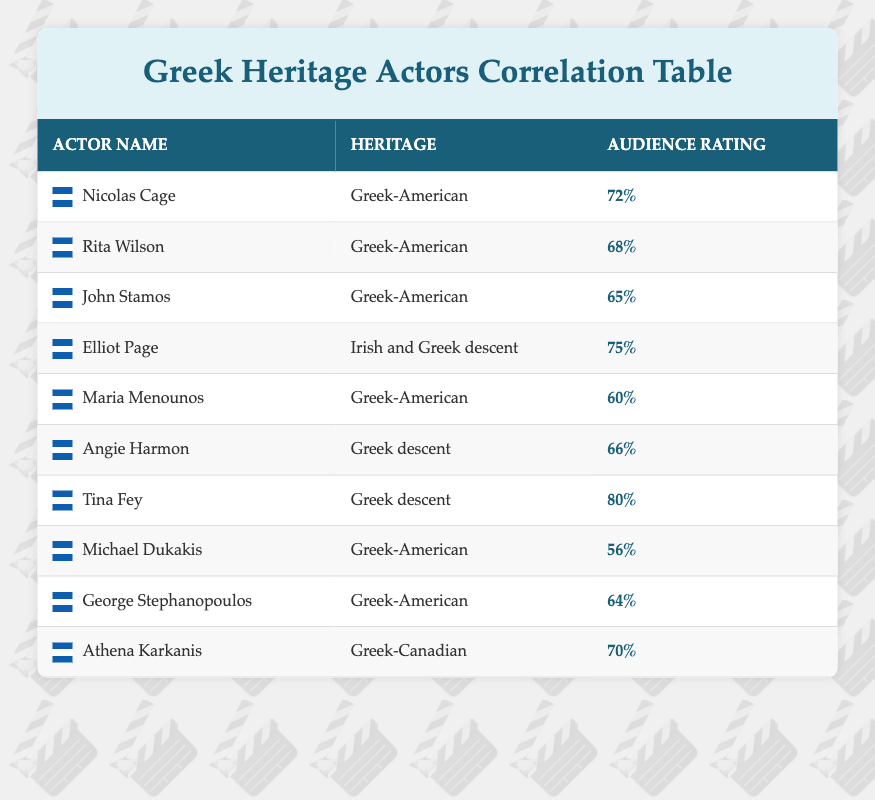What is the highest audience rating among the actors listed? To find the highest audience rating, we need to compare the numbers in the "Audience Rating" column. The highest rating is observed for Tina Fey, who has a rating of 80%.
Answer: 80% Which actor has the lowest audience rating? By examining the "Audience Rating" values, we find that Michael Dukakis has the lowest rating at 56%.
Answer: 56% How many actors have Greek-American heritage? We need to count the entries in the "Heritage" column that specifically list "Greek-American." There are 5 actors: Nicolas Cage, Rita Wilson, John Stamos, Maria Menounos, and Michael Dukakis.
Answer: 5 What is the average audience rating of actors with solely "Greek descent"? The actors with solely "Greek descent" are Elliot Page, Tina Fey, and Angie Harmon, with ratings of 75%, 80%, and 66% respectively. To find the average, we add these ratings: 75 + 80 + 66 = 221, and then divide by 3 (the number of actors): 221 / 3 = 73.67. The average is approximately 73.67%.
Answer: 73.67% Is there an actor with both Greek and Irish heritage in the list? We can scan the "Heritage" column to check for any actors listed with "Irish" heritage combined with Greek. Elliot Page is the only actor with this combined heritage.
Answer: Yes What is the total audience rating for all the Greek-American actors? The following actors are Greek-American: Nicolas Cage (72%), Rita Wilson (68%), John Stamos (65%), Maria Menounos (60%), and Michael Dukakis (56%). Adding these together gives us: 72 + 68 + 65 + 60 + 56 = 321.
Answer: 321 Are there more actors with Greek-American heritage or those with Greek descent? The count of Greek-American actors is 5 (Nicolas Cage, Rita Wilson, John Stamos, Maria Menounos, and Michael Dukakis) while the Greek descent actors are 3 (Elliot Page, Angie Harmon, and Tina Fey). Since 5 > 3, we conclude there are more Greek-American actors.
Answer: Greek-American actors What is the median audience rating of the actors listed? To find the median, we first sort the audience ratings in ascending order: 56, 60, 65, 66, 68, 70, 72, 75, 80. There are 10 ratings, so the median will be the average of the 5th and 6th values (68 and 70): (68 + 70) / 2 = 69.
Answer: 69 